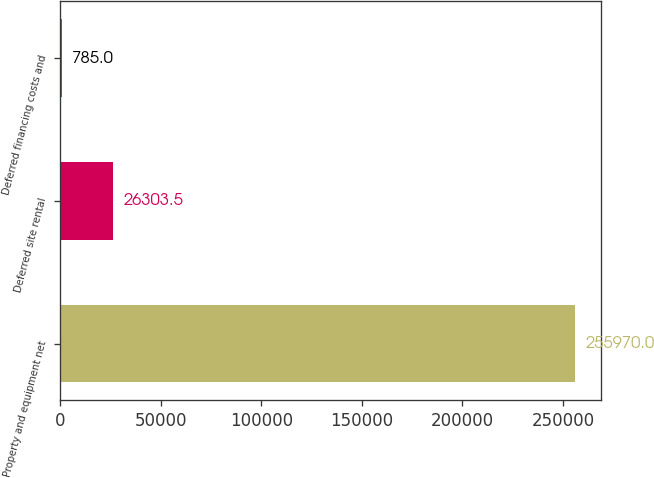Convert chart. <chart><loc_0><loc_0><loc_500><loc_500><bar_chart><fcel>Property and equipment net<fcel>Deferred site rental<fcel>Deferred financing costs and<nl><fcel>255970<fcel>26303.5<fcel>785<nl></chart> 